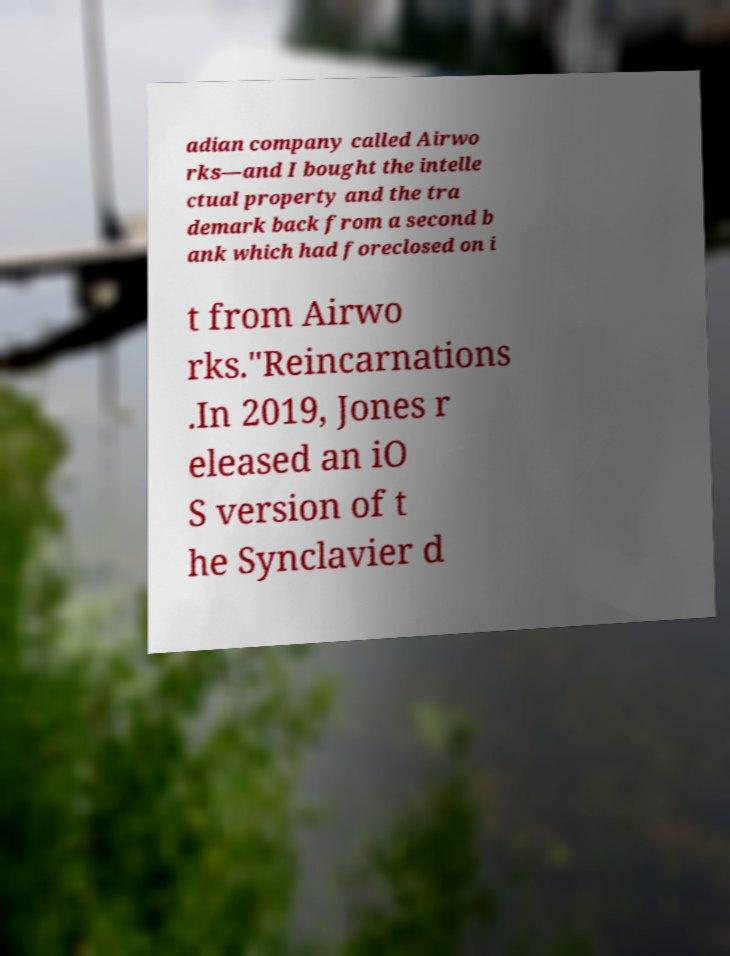Could you assist in decoding the text presented in this image and type it out clearly? adian company called Airwo rks—and I bought the intelle ctual property and the tra demark back from a second b ank which had foreclosed on i t from Airwo rks."Reincarnations .In 2019, Jones r eleased an iO S version of t he Synclavier d 